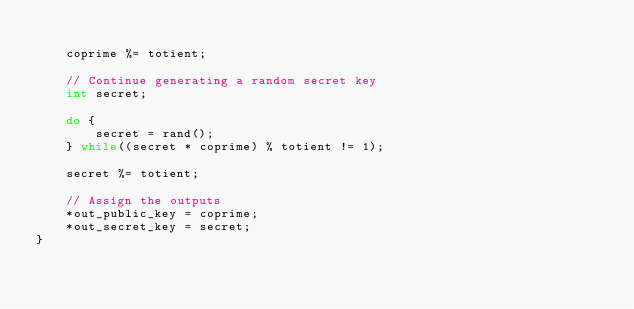Convert code to text. <code><loc_0><loc_0><loc_500><loc_500><_C_>
    coprime %= totient;

    // Continue generating a random secret key
    int secret;

    do {
        secret = rand();
    } while((secret * coprime) % totient != 1);

    secret %= totient;

    // Assign the outputs
    *out_public_key = coprime;
    *out_secret_key = secret;
}</code> 